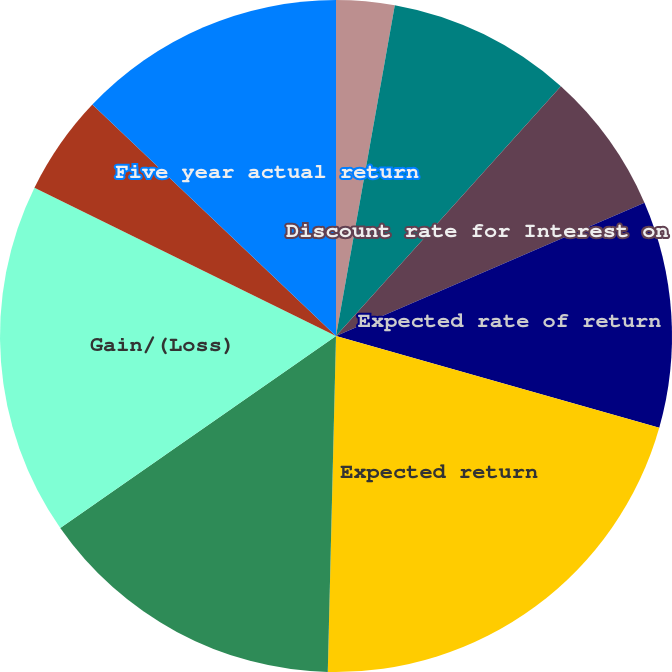Convert chart. <chart><loc_0><loc_0><loc_500><loc_500><pie_chart><fcel>Discount rate for PBO<fcel>Discount rate for Service Cost<fcel>Discount rate for Interest on<fcel>Expected rate of return<fcel>Expected return<fcel>Actual return<fcel>Gain/(Loss)<fcel>One year actual return<fcel>Five year actual return<nl><fcel>2.8%<fcel>8.87%<fcel>6.84%<fcel>10.89%<fcel>20.99%<fcel>14.93%<fcel>16.95%<fcel>4.82%<fcel>12.91%<nl></chart> 